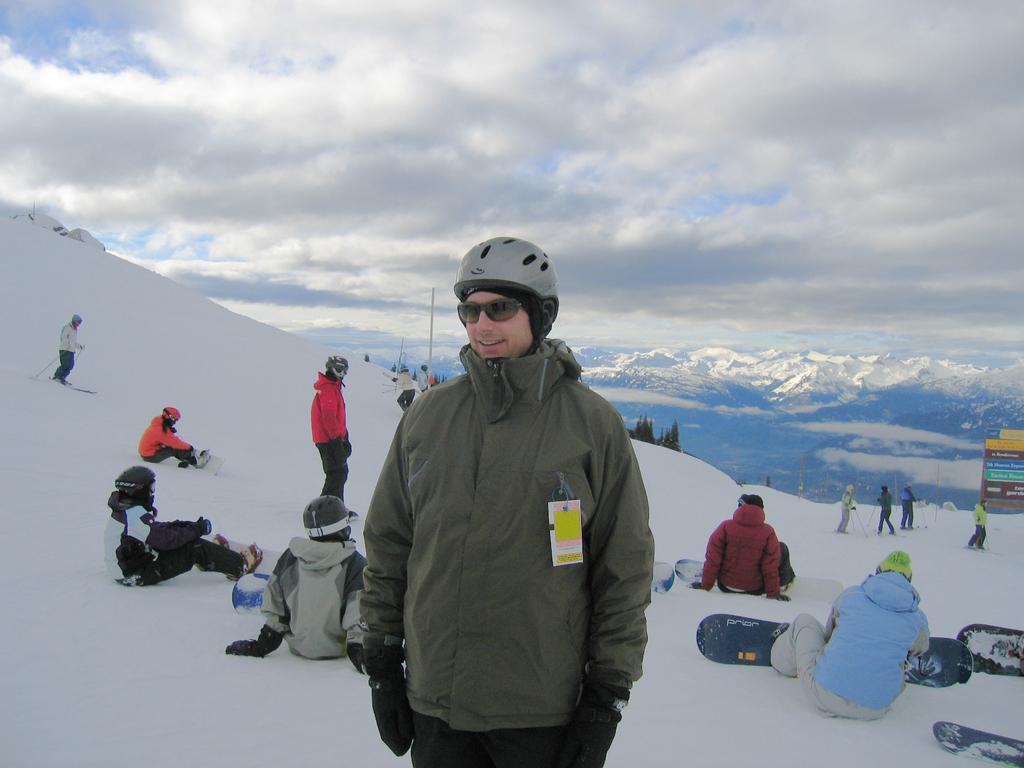Can you describe this image briefly? In the center of the image we can see a man wearing glasses and smiling. In the background we can see a few people. We can also see some trees and also the mountains. On the right there are hoardings. There is a cloudy sky. 